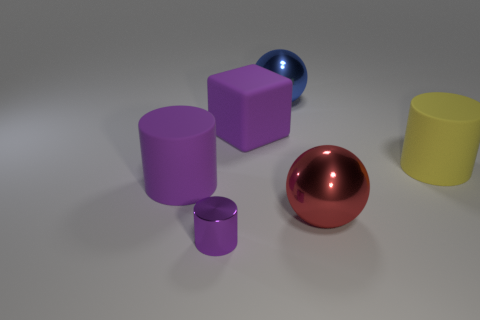Is the color of the big rubber cube the same as the tiny cylinder?
Provide a succinct answer. Yes. There is a tiny cylinder that is the same color as the block; what is its material?
Give a very brief answer. Metal. What number of large yellow cylinders have the same material as the purple cube?
Give a very brief answer. 1. Do the metal ball that is behind the purple cube and the large purple matte cylinder have the same size?
Your response must be concise. Yes. What is the color of the big cube that is the same material as the large yellow cylinder?
Give a very brief answer. Purple. Is there anything else that has the same size as the purple metal object?
Provide a short and direct response. No. There is a red object; how many red things are to the left of it?
Keep it short and to the point. 0. There is a large matte object on the left side of the big purple matte block; is its color the same as the metallic object in front of the red sphere?
Offer a very short reply. Yes. The other thing that is the same shape as the blue object is what color?
Keep it short and to the point. Red. There is a metal thing behind the large red shiny thing; is its shape the same as the large thing that is to the left of the big purple block?
Keep it short and to the point. No. 